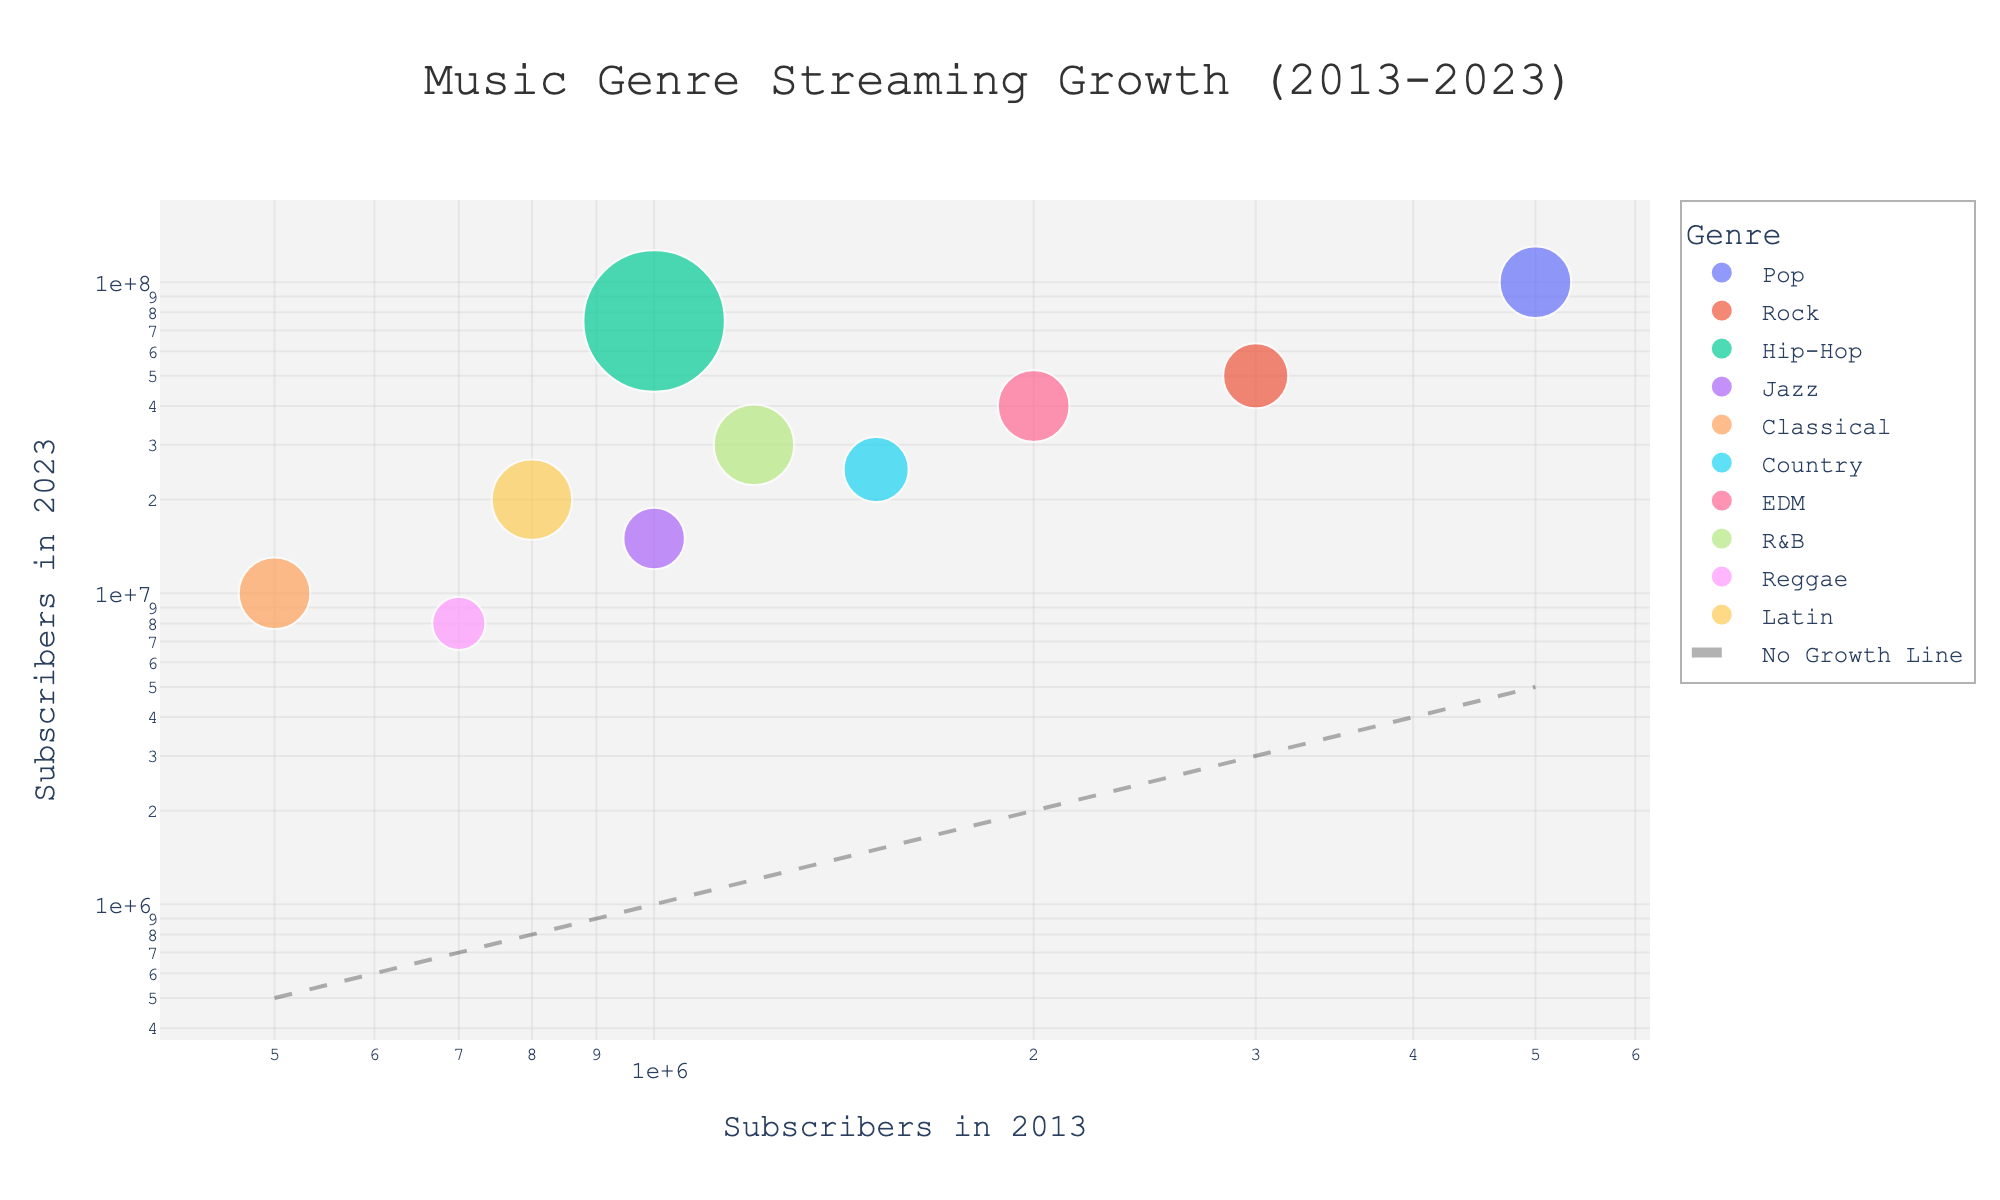What is the title of the scatter plot? The title of the scatter plot is usually found at the top center of the chart. In this case, it shows "Music Genre Streaming Growth (2013-2023)".
Answer: Music Genre Streaming Growth (2013-2023) What do the axes represent? The x-axis represents "Subscribers in 2013," and the y-axis represents "Subscribers in 2023". These axes show the number of subscribers at the start and end of the decade.
Answer: Subscribers in 2013 and Subscribers in 2023 Which genre has the highest number of subscribers in 2023? By looking at the y-axis (Subscribers in 2023), the highest point is associated with the "Pop" genre. It shows 100,000,000 subscribers in 2023.
Answer: Pop Which music genres had fewer than 1 million subscribers in 2013? To identify genres with fewer than 1 million subscribers in 2013, look left of the x=1,000,000 line on the log-scaled x-axis. "Classical," "Reggae," and "Latin" fall into this category.
Answer: Classical, Reggae, Latin What is the growth rate for the EDM genre? The size of the bubbles represents the growth rate. Hover over or reference the bubble for EDM, which indicates the growth rate. The information shows a growth rate of 19.0 (from 2,000,000 to 40,000,000 subscribers).
Answer: 19.0 How does the growth rate of Hip-Hop compare to that of Jazz? We need to compare the sizes of the "Hip-Hop" and "Jazz" bubbles. "Hip-Hop" has a larger bubble, indicating a higher growth rate. Hip-Hop grows from 1,000,000 to 75,000,000 (74 times), while Jazz grows from 1,000,000 to 15,000,000 (14 times).
Answer: Hip-Hop has a higher growth rate than Jazz Which genres have subscribers in 2023 that are greater than or equal to 10 times their subscribers in 2013? Check for bubbles whose y-value is at least 10 times their x-value. Genres like "Pop," "Hip-Hop," "Country," "EDM," "Latin," and "R&B" meet this criterion.
Answer: Pop, Hip-Hop, Country, EDM, Latin, R&B What is the approximate median growth rate across all genres? To find this, list the Growth Rates, sort them, and find the median value. Sorted rates: 7.0, 9.4, 10.0, 12.3, 13.0, 16.7, 19.0, 20.0, 21.7, 74.0. Median of 10 values is the average of 5th and 6th values: (13+16.7)/2 = 14.85.
Answer: 14.85 Is there a trend or pattern visible in the relationship between the 2013 and 2023 subscribers? By looking at the distribution of the bubbles along a line parallel to the "No Growth Line," genres with higher 2013 subscribers generally maintain higher 2023 subscribers, but their positions above this reference line indicate significant growth.
Answer: Higher initial subscribers trend to higher final subscribers, significant growth evident 